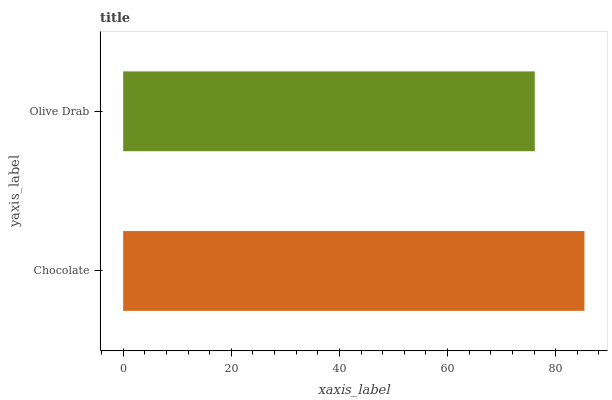Is Olive Drab the minimum?
Answer yes or no. Yes. Is Chocolate the maximum?
Answer yes or no. Yes. Is Olive Drab the maximum?
Answer yes or no. No. Is Chocolate greater than Olive Drab?
Answer yes or no. Yes. Is Olive Drab less than Chocolate?
Answer yes or no. Yes. Is Olive Drab greater than Chocolate?
Answer yes or no. No. Is Chocolate less than Olive Drab?
Answer yes or no. No. Is Chocolate the high median?
Answer yes or no. Yes. Is Olive Drab the low median?
Answer yes or no. Yes. Is Olive Drab the high median?
Answer yes or no. No. Is Chocolate the low median?
Answer yes or no. No. 